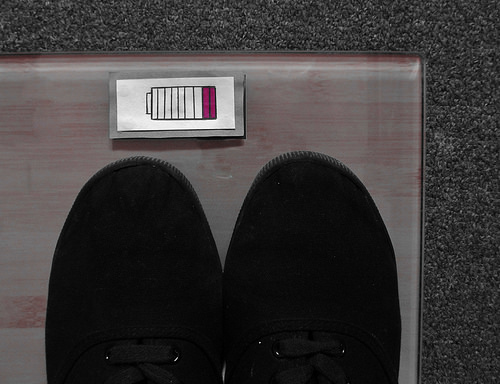<image>
Is there a shoe on the carpet? No. The shoe is not positioned on the carpet. They may be near each other, but the shoe is not supported by or resting on top of the carpet. 